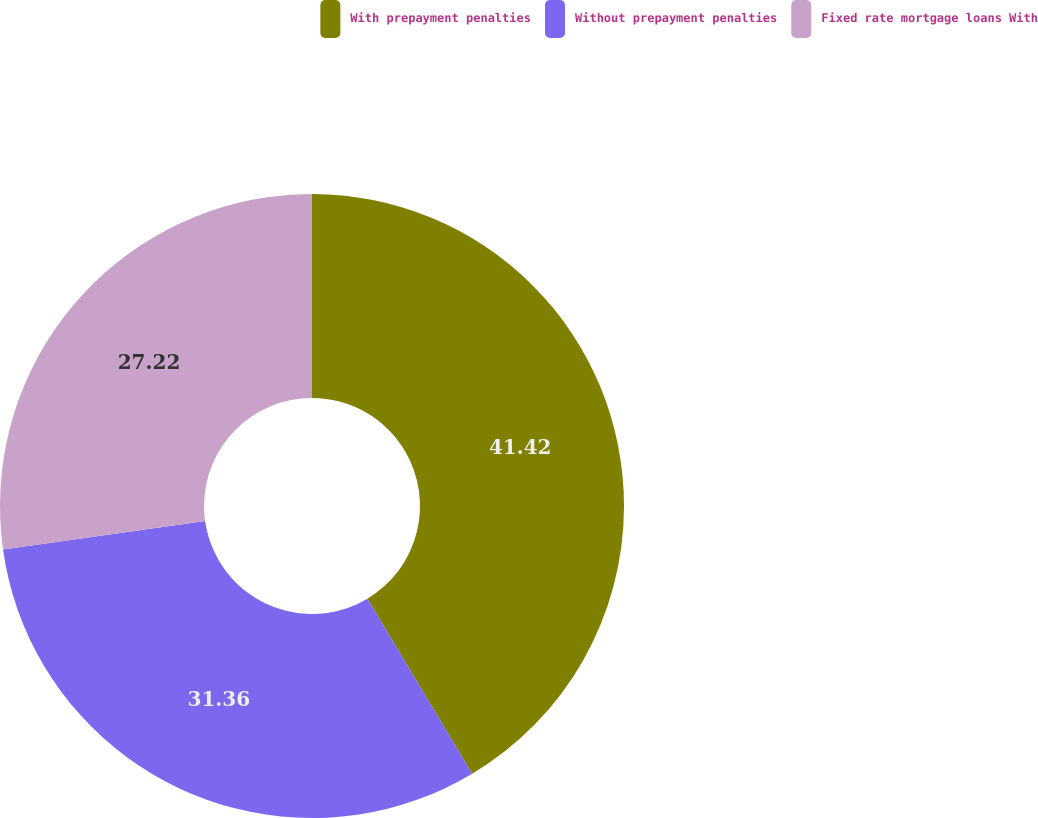Convert chart to OTSL. <chart><loc_0><loc_0><loc_500><loc_500><pie_chart><fcel>With prepayment penalties<fcel>Without prepayment penalties<fcel>Fixed rate mortgage loans With<nl><fcel>41.42%<fcel>31.36%<fcel>27.22%<nl></chart> 